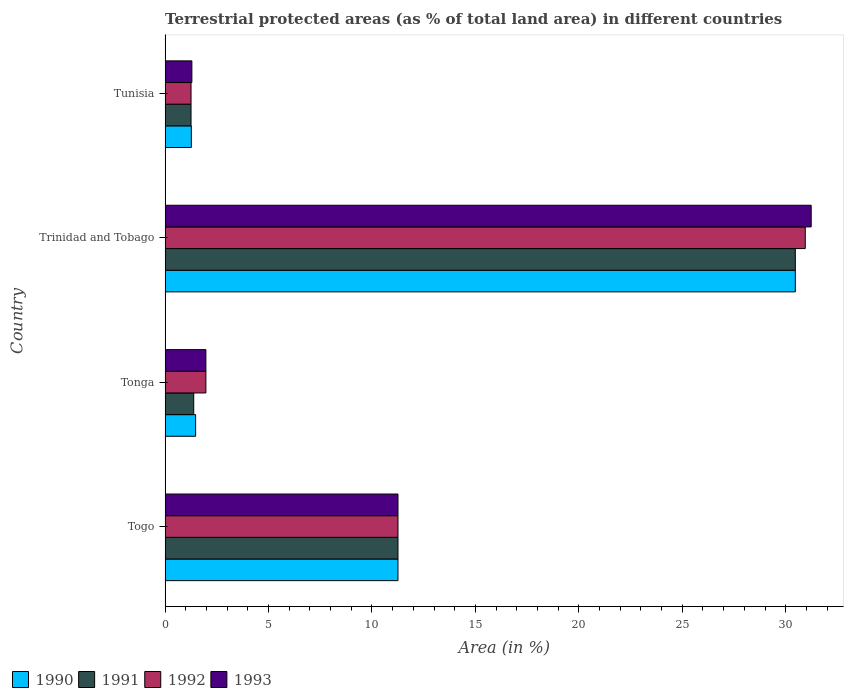Are the number of bars on each tick of the Y-axis equal?
Ensure brevity in your answer.  Yes. What is the label of the 1st group of bars from the top?
Your answer should be compact. Tunisia. What is the percentage of terrestrial protected land in 1993 in Tonga?
Give a very brief answer. 1.97. Across all countries, what is the maximum percentage of terrestrial protected land in 1991?
Keep it short and to the point. 30.46. Across all countries, what is the minimum percentage of terrestrial protected land in 1992?
Provide a short and direct response. 1.25. In which country was the percentage of terrestrial protected land in 1990 maximum?
Your answer should be very brief. Trinidad and Tobago. In which country was the percentage of terrestrial protected land in 1990 minimum?
Provide a short and direct response. Tunisia. What is the total percentage of terrestrial protected land in 1993 in the graph?
Keep it short and to the point. 45.75. What is the difference between the percentage of terrestrial protected land in 1993 in Tonga and that in Tunisia?
Your response must be concise. 0.68. What is the difference between the percentage of terrestrial protected land in 1990 in Tunisia and the percentage of terrestrial protected land in 1993 in Trinidad and Tobago?
Keep it short and to the point. -29.96. What is the average percentage of terrestrial protected land in 1993 per country?
Make the answer very short. 11.44. What is the difference between the percentage of terrestrial protected land in 1990 and percentage of terrestrial protected land in 1992 in Tunisia?
Give a very brief answer. 0.01. In how many countries, is the percentage of terrestrial protected land in 1991 greater than 17 %?
Provide a short and direct response. 1. What is the ratio of the percentage of terrestrial protected land in 1990 in Tonga to that in Tunisia?
Your answer should be compact. 1.16. Is the percentage of terrestrial protected land in 1990 in Togo less than that in Tunisia?
Ensure brevity in your answer.  No. Is the difference between the percentage of terrestrial protected land in 1990 in Togo and Trinidad and Tobago greater than the difference between the percentage of terrestrial protected land in 1992 in Togo and Trinidad and Tobago?
Ensure brevity in your answer.  Yes. What is the difference between the highest and the second highest percentage of terrestrial protected land in 1993?
Your answer should be very brief. 19.97. What is the difference between the highest and the lowest percentage of terrestrial protected land in 1991?
Your answer should be very brief. 29.21. In how many countries, is the percentage of terrestrial protected land in 1993 greater than the average percentage of terrestrial protected land in 1993 taken over all countries?
Your response must be concise. 1. Is the sum of the percentage of terrestrial protected land in 1991 in Tonga and Trinidad and Tobago greater than the maximum percentage of terrestrial protected land in 1992 across all countries?
Ensure brevity in your answer.  Yes. Is it the case that in every country, the sum of the percentage of terrestrial protected land in 1991 and percentage of terrestrial protected land in 1992 is greater than the sum of percentage of terrestrial protected land in 1990 and percentage of terrestrial protected land in 1993?
Keep it short and to the point. No. Is it the case that in every country, the sum of the percentage of terrestrial protected land in 1990 and percentage of terrestrial protected land in 1993 is greater than the percentage of terrestrial protected land in 1991?
Provide a short and direct response. Yes. How many bars are there?
Provide a succinct answer. 16. How many countries are there in the graph?
Keep it short and to the point. 4. How are the legend labels stacked?
Your answer should be very brief. Horizontal. What is the title of the graph?
Your response must be concise. Terrestrial protected areas (as % of total land area) in different countries. What is the label or title of the X-axis?
Your answer should be very brief. Area (in %). What is the label or title of the Y-axis?
Your answer should be very brief. Country. What is the Area (in %) of 1990 in Togo?
Provide a succinct answer. 11.26. What is the Area (in %) in 1991 in Togo?
Give a very brief answer. 11.26. What is the Area (in %) in 1992 in Togo?
Provide a short and direct response. 11.26. What is the Area (in %) of 1993 in Togo?
Keep it short and to the point. 11.26. What is the Area (in %) in 1990 in Tonga?
Your response must be concise. 1.48. What is the Area (in %) of 1991 in Tonga?
Your response must be concise. 1.38. What is the Area (in %) in 1992 in Tonga?
Keep it short and to the point. 1.97. What is the Area (in %) of 1993 in Tonga?
Offer a very short reply. 1.97. What is the Area (in %) in 1990 in Trinidad and Tobago?
Make the answer very short. 30.46. What is the Area (in %) in 1991 in Trinidad and Tobago?
Your response must be concise. 30.46. What is the Area (in %) of 1992 in Trinidad and Tobago?
Provide a succinct answer. 30.94. What is the Area (in %) in 1993 in Trinidad and Tobago?
Provide a succinct answer. 31.23. What is the Area (in %) in 1990 in Tunisia?
Your response must be concise. 1.27. What is the Area (in %) of 1991 in Tunisia?
Offer a very short reply. 1.25. What is the Area (in %) of 1992 in Tunisia?
Provide a succinct answer. 1.25. What is the Area (in %) of 1993 in Tunisia?
Ensure brevity in your answer.  1.29. Across all countries, what is the maximum Area (in %) of 1990?
Give a very brief answer. 30.46. Across all countries, what is the maximum Area (in %) in 1991?
Offer a very short reply. 30.46. Across all countries, what is the maximum Area (in %) of 1992?
Keep it short and to the point. 30.94. Across all countries, what is the maximum Area (in %) in 1993?
Your response must be concise. 31.23. Across all countries, what is the minimum Area (in %) of 1990?
Provide a succinct answer. 1.27. Across all countries, what is the minimum Area (in %) of 1991?
Provide a short and direct response. 1.25. Across all countries, what is the minimum Area (in %) of 1992?
Your answer should be compact. 1.25. Across all countries, what is the minimum Area (in %) in 1993?
Provide a succinct answer. 1.29. What is the total Area (in %) of 1990 in the graph?
Your response must be concise. 44.46. What is the total Area (in %) in 1991 in the graph?
Your answer should be very brief. 44.36. What is the total Area (in %) of 1992 in the graph?
Offer a terse response. 45.43. What is the total Area (in %) in 1993 in the graph?
Your response must be concise. 45.75. What is the difference between the Area (in %) of 1990 in Togo and that in Tonga?
Provide a short and direct response. 9.78. What is the difference between the Area (in %) of 1991 in Togo and that in Tonga?
Provide a short and direct response. 9.87. What is the difference between the Area (in %) in 1992 in Togo and that in Tonga?
Offer a terse response. 9.29. What is the difference between the Area (in %) in 1993 in Togo and that in Tonga?
Provide a succinct answer. 9.29. What is the difference between the Area (in %) of 1990 in Togo and that in Trinidad and Tobago?
Give a very brief answer. -19.21. What is the difference between the Area (in %) in 1991 in Togo and that in Trinidad and Tobago?
Give a very brief answer. -19.21. What is the difference between the Area (in %) of 1992 in Togo and that in Trinidad and Tobago?
Offer a very short reply. -19.69. What is the difference between the Area (in %) in 1993 in Togo and that in Trinidad and Tobago?
Your answer should be compact. -19.97. What is the difference between the Area (in %) of 1990 in Togo and that in Tunisia?
Keep it short and to the point. 9.99. What is the difference between the Area (in %) in 1991 in Togo and that in Tunisia?
Ensure brevity in your answer.  10. What is the difference between the Area (in %) of 1992 in Togo and that in Tunisia?
Make the answer very short. 10. What is the difference between the Area (in %) in 1993 in Togo and that in Tunisia?
Your answer should be compact. 9.96. What is the difference between the Area (in %) of 1990 in Tonga and that in Trinidad and Tobago?
Give a very brief answer. -28.99. What is the difference between the Area (in %) of 1991 in Tonga and that in Trinidad and Tobago?
Offer a very short reply. -29.08. What is the difference between the Area (in %) of 1992 in Tonga and that in Trinidad and Tobago?
Provide a short and direct response. -28.97. What is the difference between the Area (in %) in 1993 in Tonga and that in Trinidad and Tobago?
Your answer should be compact. -29.26. What is the difference between the Area (in %) of 1990 in Tonga and that in Tunisia?
Ensure brevity in your answer.  0.21. What is the difference between the Area (in %) in 1991 in Tonga and that in Tunisia?
Your response must be concise. 0.13. What is the difference between the Area (in %) of 1992 in Tonga and that in Tunisia?
Your response must be concise. 0.72. What is the difference between the Area (in %) of 1993 in Tonga and that in Tunisia?
Keep it short and to the point. 0.68. What is the difference between the Area (in %) of 1990 in Trinidad and Tobago and that in Tunisia?
Your response must be concise. 29.2. What is the difference between the Area (in %) in 1991 in Trinidad and Tobago and that in Tunisia?
Keep it short and to the point. 29.21. What is the difference between the Area (in %) in 1992 in Trinidad and Tobago and that in Tunisia?
Ensure brevity in your answer.  29.69. What is the difference between the Area (in %) of 1993 in Trinidad and Tobago and that in Tunisia?
Your response must be concise. 29.94. What is the difference between the Area (in %) in 1990 in Togo and the Area (in %) in 1991 in Tonga?
Your answer should be compact. 9.87. What is the difference between the Area (in %) of 1990 in Togo and the Area (in %) of 1992 in Tonga?
Your response must be concise. 9.29. What is the difference between the Area (in %) of 1990 in Togo and the Area (in %) of 1993 in Tonga?
Make the answer very short. 9.29. What is the difference between the Area (in %) of 1991 in Togo and the Area (in %) of 1992 in Tonga?
Your response must be concise. 9.29. What is the difference between the Area (in %) of 1991 in Togo and the Area (in %) of 1993 in Tonga?
Your answer should be very brief. 9.29. What is the difference between the Area (in %) of 1992 in Togo and the Area (in %) of 1993 in Tonga?
Make the answer very short. 9.29. What is the difference between the Area (in %) of 1990 in Togo and the Area (in %) of 1991 in Trinidad and Tobago?
Give a very brief answer. -19.21. What is the difference between the Area (in %) in 1990 in Togo and the Area (in %) in 1992 in Trinidad and Tobago?
Your answer should be very brief. -19.69. What is the difference between the Area (in %) of 1990 in Togo and the Area (in %) of 1993 in Trinidad and Tobago?
Keep it short and to the point. -19.97. What is the difference between the Area (in %) in 1991 in Togo and the Area (in %) in 1992 in Trinidad and Tobago?
Your answer should be very brief. -19.69. What is the difference between the Area (in %) in 1991 in Togo and the Area (in %) in 1993 in Trinidad and Tobago?
Provide a short and direct response. -19.97. What is the difference between the Area (in %) of 1992 in Togo and the Area (in %) of 1993 in Trinidad and Tobago?
Keep it short and to the point. -19.97. What is the difference between the Area (in %) of 1990 in Togo and the Area (in %) of 1991 in Tunisia?
Your answer should be very brief. 10. What is the difference between the Area (in %) of 1990 in Togo and the Area (in %) of 1992 in Tunisia?
Make the answer very short. 10. What is the difference between the Area (in %) in 1990 in Togo and the Area (in %) in 1993 in Tunisia?
Offer a very short reply. 9.96. What is the difference between the Area (in %) of 1991 in Togo and the Area (in %) of 1992 in Tunisia?
Provide a short and direct response. 10. What is the difference between the Area (in %) of 1991 in Togo and the Area (in %) of 1993 in Tunisia?
Your answer should be compact. 9.96. What is the difference between the Area (in %) of 1992 in Togo and the Area (in %) of 1993 in Tunisia?
Provide a short and direct response. 9.96. What is the difference between the Area (in %) of 1990 in Tonga and the Area (in %) of 1991 in Trinidad and Tobago?
Your answer should be compact. -28.99. What is the difference between the Area (in %) in 1990 in Tonga and the Area (in %) in 1992 in Trinidad and Tobago?
Offer a very short reply. -29.47. What is the difference between the Area (in %) in 1990 in Tonga and the Area (in %) in 1993 in Trinidad and Tobago?
Keep it short and to the point. -29.75. What is the difference between the Area (in %) of 1991 in Tonga and the Area (in %) of 1992 in Trinidad and Tobago?
Provide a succinct answer. -29.56. What is the difference between the Area (in %) in 1991 in Tonga and the Area (in %) in 1993 in Trinidad and Tobago?
Offer a very short reply. -29.85. What is the difference between the Area (in %) in 1992 in Tonga and the Area (in %) in 1993 in Trinidad and Tobago?
Make the answer very short. -29.26. What is the difference between the Area (in %) in 1990 in Tonga and the Area (in %) in 1991 in Tunisia?
Give a very brief answer. 0.22. What is the difference between the Area (in %) of 1990 in Tonga and the Area (in %) of 1992 in Tunisia?
Keep it short and to the point. 0.22. What is the difference between the Area (in %) of 1990 in Tonga and the Area (in %) of 1993 in Tunisia?
Your response must be concise. 0.18. What is the difference between the Area (in %) of 1991 in Tonga and the Area (in %) of 1992 in Tunisia?
Ensure brevity in your answer.  0.13. What is the difference between the Area (in %) in 1991 in Tonga and the Area (in %) in 1993 in Tunisia?
Give a very brief answer. 0.09. What is the difference between the Area (in %) in 1992 in Tonga and the Area (in %) in 1993 in Tunisia?
Your response must be concise. 0.68. What is the difference between the Area (in %) of 1990 in Trinidad and Tobago and the Area (in %) of 1991 in Tunisia?
Your response must be concise. 29.21. What is the difference between the Area (in %) in 1990 in Trinidad and Tobago and the Area (in %) in 1992 in Tunisia?
Give a very brief answer. 29.21. What is the difference between the Area (in %) of 1990 in Trinidad and Tobago and the Area (in %) of 1993 in Tunisia?
Keep it short and to the point. 29.17. What is the difference between the Area (in %) in 1991 in Trinidad and Tobago and the Area (in %) in 1992 in Tunisia?
Your answer should be compact. 29.21. What is the difference between the Area (in %) in 1991 in Trinidad and Tobago and the Area (in %) in 1993 in Tunisia?
Offer a very short reply. 29.17. What is the difference between the Area (in %) in 1992 in Trinidad and Tobago and the Area (in %) in 1993 in Tunisia?
Provide a succinct answer. 29.65. What is the average Area (in %) in 1990 per country?
Ensure brevity in your answer.  11.12. What is the average Area (in %) of 1991 per country?
Make the answer very short. 11.09. What is the average Area (in %) in 1992 per country?
Ensure brevity in your answer.  11.36. What is the average Area (in %) of 1993 per country?
Offer a terse response. 11.44. What is the difference between the Area (in %) of 1990 and Area (in %) of 1991 in Togo?
Your answer should be very brief. 0. What is the difference between the Area (in %) in 1990 and Area (in %) in 1992 in Togo?
Offer a very short reply. 0. What is the difference between the Area (in %) of 1990 and Area (in %) of 1993 in Togo?
Keep it short and to the point. 0. What is the difference between the Area (in %) of 1992 and Area (in %) of 1993 in Togo?
Your answer should be very brief. 0. What is the difference between the Area (in %) in 1990 and Area (in %) in 1991 in Tonga?
Offer a terse response. 0.09. What is the difference between the Area (in %) of 1990 and Area (in %) of 1992 in Tonga?
Your response must be concise. -0.5. What is the difference between the Area (in %) in 1990 and Area (in %) in 1993 in Tonga?
Offer a very short reply. -0.5. What is the difference between the Area (in %) of 1991 and Area (in %) of 1992 in Tonga?
Offer a very short reply. -0.59. What is the difference between the Area (in %) in 1991 and Area (in %) in 1993 in Tonga?
Your answer should be very brief. -0.59. What is the difference between the Area (in %) in 1992 and Area (in %) in 1993 in Tonga?
Make the answer very short. 0. What is the difference between the Area (in %) of 1990 and Area (in %) of 1991 in Trinidad and Tobago?
Offer a terse response. 0. What is the difference between the Area (in %) in 1990 and Area (in %) in 1992 in Trinidad and Tobago?
Offer a very short reply. -0.48. What is the difference between the Area (in %) of 1990 and Area (in %) of 1993 in Trinidad and Tobago?
Provide a succinct answer. -0.77. What is the difference between the Area (in %) of 1991 and Area (in %) of 1992 in Trinidad and Tobago?
Your response must be concise. -0.48. What is the difference between the Area (in %) of 1991 and Area (in %) of 1993 in Trinidad and Tobago?
Your response must be concise. -0.77. What is the difference between the Area (in %) of 1992 and Area (in %) of 1993 in Trinidad and Tobago?
Provide a short and direct response. -0.29. What is the difference between the Area (in %) in 1990 and Area (in %) in 1991 in Tunisia?
Ensure brevity in your answer.  0.01. What is the difference between the Area (in %) of 1990 and Area (in %) of 1992 in Tunisia?
Offer a terse response. 0.01. What is the difference between the Area (in %) of 1990 and Area (in %) of 1993 in Tunisia?
Make the answer very short. -0.03. What is the difference between the Area (in %) in 1991 and Area (in %) in 1992 in Tunisia?
Ensure brevity in your answer.  0. What is the difference between the Area (in %) of 1991 and Area (in %) of 1993 in Tunisia?
Your answer should be compact. -0.04. What is the difference between the Area (in %) of 1992 and Area (in %) of 1993 in Tunisia?
Your answer should be very brief. -0.04. What is the ratio of the Area (in %) of 1990 in Togo to that in Tonga?
Provide a succinct answer. 7.63. What is the ratio of the Area (in %) of 1991 in Togo to that in Tonga?
Make the answer very short. 8.13. What is the ratio of the Area (in %) of 1992 in Togo to that in Tonga?
Offer a terse response. 5.71. What is the ratio of the Area (in %) of 1993 in Togo to that in Tonga?
Keep it short and to the point. 5.71. What is the ratio of the Area (in %) in 1990 in Togo to that in Trinidad and Tobago?
Provide a short and direct response. 0.37. What is the ratio of the Area (in %) in 1991 in Togo to that in Trinidad and Tobago?
Ensure brevity in your answer.  0.37. What is the ratio of the Area (in %) in 1992 in Togo to that in Trinidad and Tobago?
Provide a succinct answer. 0.36. What is the ratio of the Area (in %) of 1993 in Togo to that in Trinidad and Tobago?
Your answer should be compact. 0.36. What is the ratio of the Area (in %) of 1990 in Togo to that in Tunisia?
Keep it short and to the point. 8.87. What is the ratio of the Area (in %) of 1991 in Togo to that in Tunisia?
Keep it short and to the point. 8.98. What is the ratio of the Area (in %) in 1992 in Togo to that in Tunisia?
Provide a succinct answer. 8.98. What is the ratio of the Area (in %) in 1993 in Togo to that in Tunisia?
Make the answer very short. 8.7. What is the ratio of the Area (in %) of 1990 in Tonga to that in Trinidad and Tobago?
Ensure brevity in your answer.  0.05. What is the ratio of the Area (in %) in 1991 in Tonga to that in Trinidad and Tobago?
Offer a terse response. 0.05. What is the ratio of the Area (in %) of 1992 in Tonga to that in Trinidad and Tobago?
Keep it short and to the point. 0.06. What is the ratio of the Area (in %) of 1993 in Tonga to that in Trinidad and Tobago?
Keep it short and to the point. 0.06. What is the ratio of the Area (in %) of 1990 in Tonga to that in Tunisia?
Provide a succinct answer. 1.16. What is the ratio of the Area (in %) of 1991 in Tonga to that in Tunisia?
Keep it short and to the point. 1.1. What is the ratio of the Area (in %) of 1992 in Tonga to that in Tunisia?
Your response must be concise. 1.57. What is the ratio of the Area (in %) of 1993 in Tonga to that in Tunisia?
Offer a terse response. 1.52. What is the ratio of the Area (in %) in 1990 in Trinidad and Tobago to that in Tunisia?
Provide a succinct answer. 24.02. What is the ratio of the Area (in %) in 1991 in Trinidad and Tobago to that in Tunisia?
Offer a terse response. 24.3. What is the ratio of the Area (in %) in 1992 in Trinidad and Tobago to that in Tunisia?
Your answer should be very brief. 24.68. What is the ratio of the Area (in %) in 1993 in Trinidad and Tobago to that in Tunisia?
Give a very brief answer. 24.13. What is the difference between the highest and the second highest Area (in %) in 1990?
Your answer should be very brief. 19.21. What is the difference between the highest and the second highest Area (in %) in 1991?
Your answer should be compact. 19.21. What is the difference between the highest and the second highest Area (in %) in 1992?
Provide a short and direct response. 19.69. What is the difference between the highest and the second highest Area (in %) in 1993?
Provide a succinct answer. 19.97. What is the difference between the highest and the lowest Area (in %) of 1990?
Ensure brevity in your answer.  29.2. What is the difference between the highest and the lowest Area (in %) of 1991?
Your answer should be very brief. 29.21. What is the difference between the highest and the lowest Area (in %) of 1992?
Your answer should be very brief. 29.69. What is the difference between the highest and the lowest Area (in %) in 1993?
Ensure brevity in your answer.  29.94. 